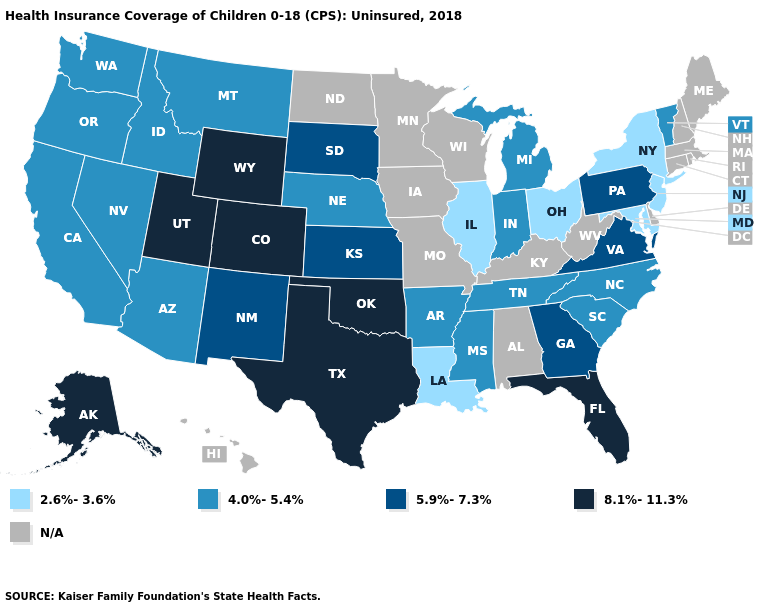Name the states that have a value in the range 5.9%-7.3%?
Give a very brief answer. Georgia, Kansas, New Mexico, Pennsylvania, South Dakota, Virginia. What is the value of Indiana?
Give a very brief answer. 4.0%-5.4%. Name the states that have a value in the range N/A?
Be succinct. Alabama, Connecticut, Delaware, Hawaii, Iowa, Kentucky, Maine, Massachusetts, Minnesota, Missouri, New Hampshire, North Dakota, Rhode Island, West Virginia, Wisconsin. How many symbols are there in the legend?
Keep it brief. 5. Does Pennsylvania have the lowest value in the USA?
Answer briefly. No. Does the first symbol in the legend represent the smallest category?
Short answer required. Yes. Name the states that have a value in the range 2.6%-3.6%?
Short answer required. Illinois, Louisiana, Maryland, New Jersey, New York, Ohio. What is the lowest value in the Northeast?
Concise answer only. 2.6%-3.6%. Name the states that have a value in the range 8.1%-11.3%?
Keep it brief. Alaska, Colorado, Florida, Oklahoma, Texas, Utah, Wyoming. Which states hav the highest value in the West?
Give a very brief answer. Alaska, Colorado, Utah, Wyoming. Among the states that border Connecticut , which have the highest value?
Give a very brief answer. New York. Is the legend a continuous bar?
Give a very brief answer. No. Does Vermont have the lowest value in the Northeast?
Quick response, please. No. Name the states that have a value in the range 5.9%-7.3%?
Keep it brief. Georgia, Kansas, New Mexico, Pennsylvania, South Dakota, Virginia. 